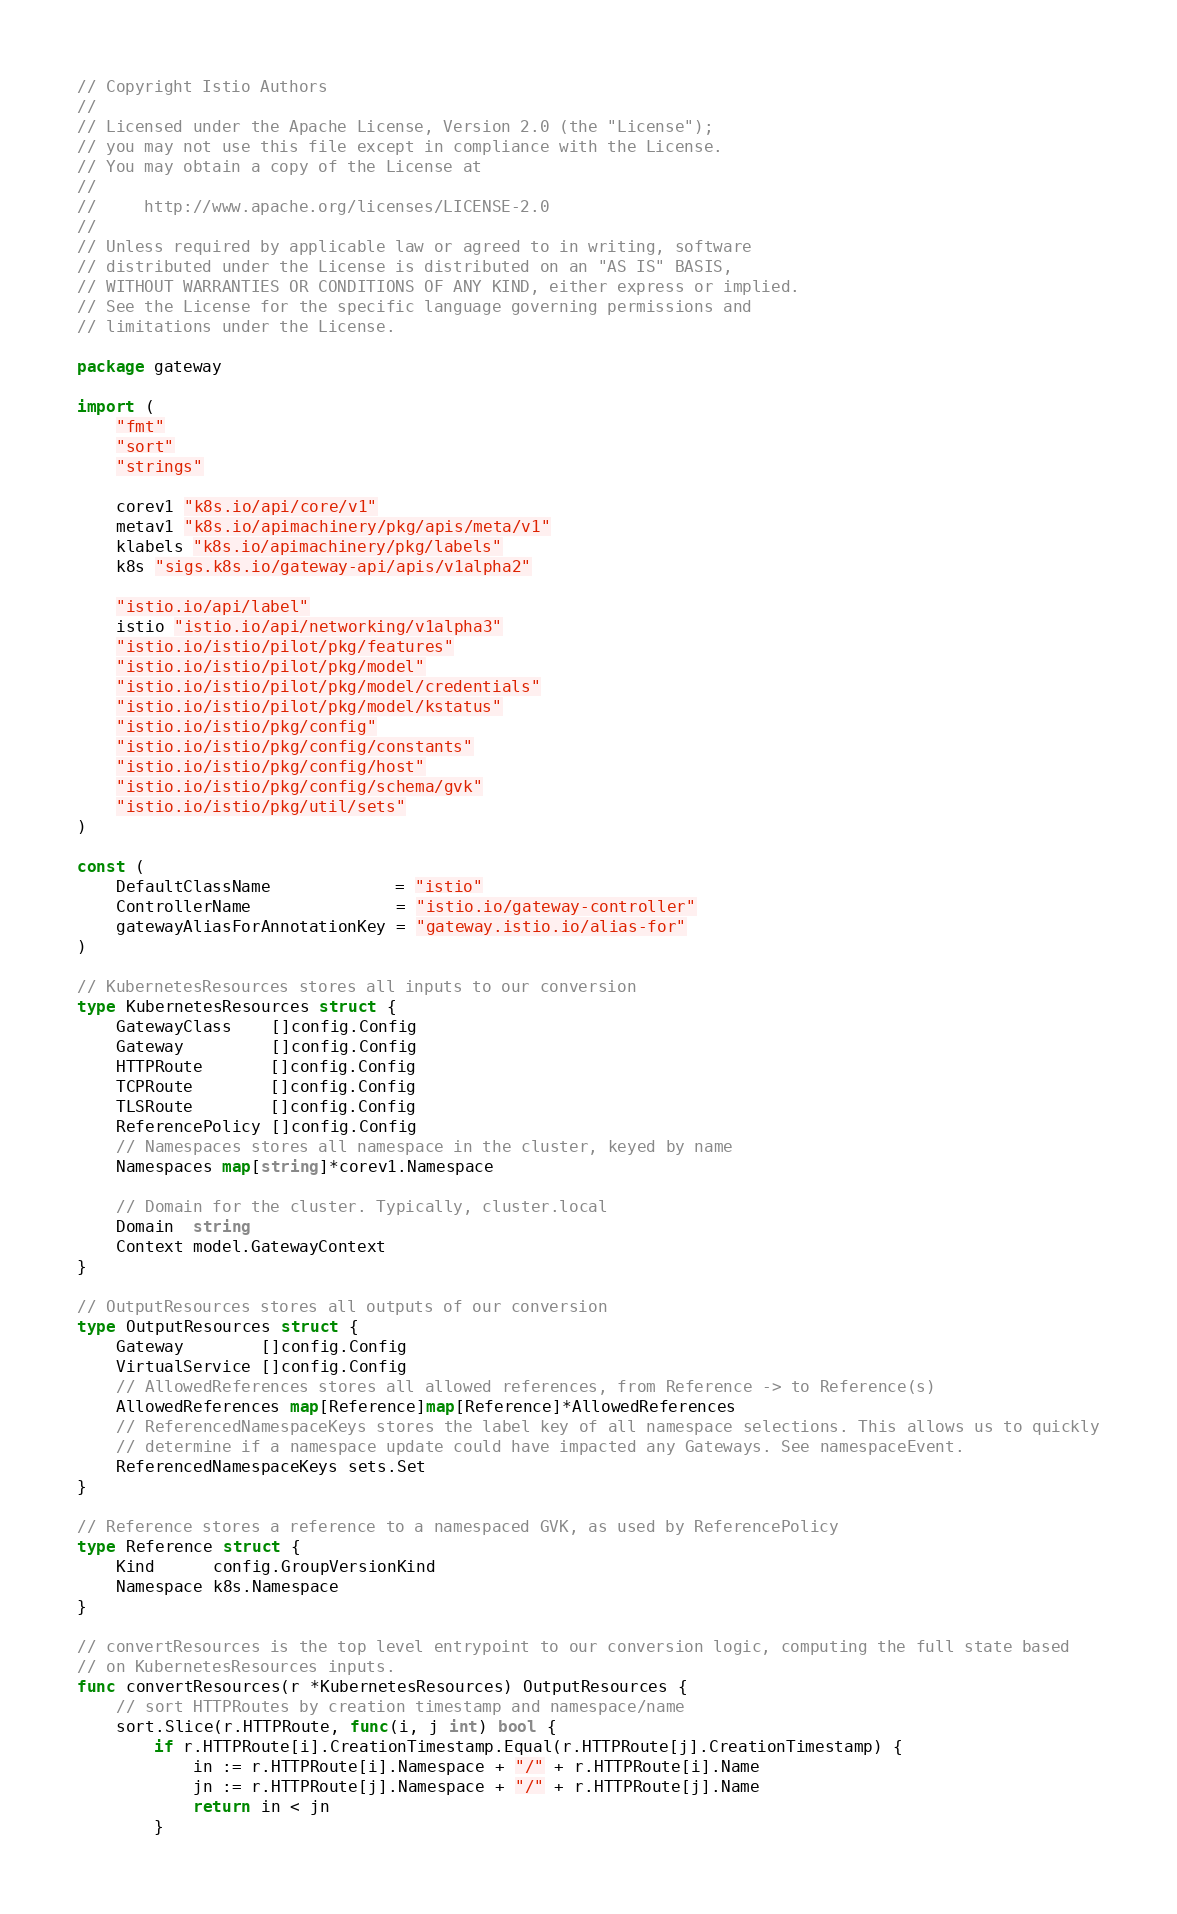<code> <loc_0><loc_0><loc_500><loc_500><_Go_>// Copyright Istio Authors
//
// Licensed under the Apache License, Version 2.0 (the "License");
// you may not use this file except in compliance with the License.
// You may obtain a copy of the License at
//
//     http://www.apache.org/licenses/LICENSE-2.0
//
// Unless required by applicable law or agreed to in writing, software
// distributed under the License is distributed on an "AS IS" BASIS,
// WITHOUT WARRANTIES OR CONDITIONS OF ANY KIND, either express or implied.
// See the License for the specific language governing permissions and
// limitations under the License.

package gateway

import (
	"fmt"
	"sort"
	"strings"

	corev1 "k8s.io/api/core/v1"
	metav1 "k8s.io/apimachinery/pkg/apis/meta/v1"
	klabels "k8s.io/apimachinery/pkg/labels"
	k8s "sigs.k8s.io/gateway-api/apis/v1alpha2"

	"istio.io/api/label"
	istio "istio.io/api/networking/v1alpha3"
	"istio.io/istio/pilot/pkg/features"
	"istio.io/istio/pilot/pkg/model"
	"istio.io/istio/pilot/pkg/model/credentials"
	"istio.io/istio/pilot/pkg/model/kstatus"
	"istio.io/istio/pkg/config"
	"istio.io/istio/pkg/config/constants"
	"istio.io/istio/pkg/config/host"
	"istio.io/istio/pkg/config/schema/gvk"
	"istio.io/istio/pkg/util/sets"
)

const (
	DefaultClassName             = "istio"
	ControllerName               = "istio.io/gateway-controller"
	gatewayAliasForAnnotationKey = "gateway.istio.io/alias-for"
)

// KubernetesResources stores all inputs to our conversion
type KubernetesResources struct {
	GatewayClass    []config.Config
	Gateway         []config.Config
	HTTPRoute       []config.Config
	TCPRoute        []config.Config
	TLSRoute        []config.Config
	ReferencePolicy []config.Config
	// Namespaces stores all namespace in the cluster, keyed by name
	Namespaces map[string]*corev1.Namespace

	// Domain for the cluster. Typically, cluster.local
	Domain  string
	Context model.GatewayContext
}

// OutputResources stores all outputs of our conversion
type OutputResources struct {
	Gateway        []config.Config
	VirtualService []config.Config
	// AllowedReferences stores all allowed references, from Reference -> to Reference(s)
	AllowedReferences map[Reference]map[Reference]*AllowedReferences
	// ReferencedNamespaceKeys stores the label key of all namespace selections. This allows us to quickly
	// determine if a namespace update could have impacted any Gateways. See namespaceEvent.
	ReferencedNamespaceKeys sets.Set
}

// Reference stores a reference to a namespaced GVK, as used by ReferencePolicy
type Reference struct {
	Kind      config.GroupVersionKind
	Namespace k8s.Namespace
}

// convertResources is the top level entrypoint to our conversion logic, computing the full state based
// on KubernetesResources inputs.
func convertResources(r *KubernetesResources) OutputResources {
	// sort HTTPRoutes by creation timestamp and namespace/name
	sort.Slice(r.HTTPRoute, func(i, j int) bool {
		if r.HTTPRoute[i].CreationTimestamp.Equal(r.HTTPRoute[j].CreationTimestamp) {
			in := r.HTTPRoute[i].Namespace + "/" + r.HTTPRoute[i].Name
			jn := r.HTTPRoute[j].Namespace + "/" + r.HTTPRoute[j].Name
			return in < jn
		}</code> 